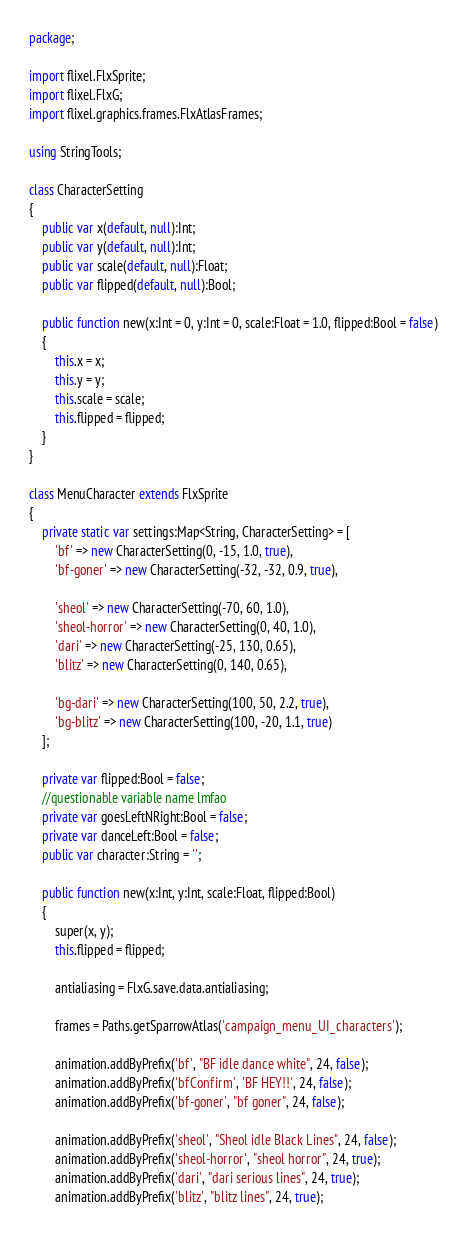<code> <loc_0><loc_0><loc_500><loc_500><_Haxe_>package;

import flixel.FlxSprite;
import flixel.FlxG;
import flixel.graphics.frames.FlxAtlasFrames;

using StringTools;

class CharacterSetting
{
	public var x(default, null):Int;
	public var y(default, null):Int;
	public var scale(default, null):Float;
	public var flipped(default, null):Bool;

	public function new(x:Int = 0, y:Int = 0, scale:Float = 1.0, flipped:Bool = false)
	{
		this.x = x;
		this.y = y;
		this.scale = scale;
		this.flipped = flipped;
	}
}

class MenuCharacter extends FlxSprite
{
	private static var settings:Map<String, CharacterSetting> = [
		'bf' => new CharacterSetting(0, -15, 1.0, true),
		'bf-goner' => new CharacterSetting(-32, -32, 0.9, true),

		'sheol' => new CharacterSetting(-70, 60, 1.0),
		'sheol-horror' => new CharacterSetting(0, 40, 1.0),
		'dari' => new CharacterSetting(-25, 130, 0.65),
		'blitz' => new CharacterSetting(0, 140, 0.65),

		'bg-dari' => new CharacterSetting(100, 50, 2.2, true),
		'bg-blitz' => new CharacterSetting(100, -20, 1.1, true)
	];

	private var flipped:Bool = false;
	//questionable variable name lmfao
	private var goesLeftNRight:Bool = false;
	private var danceLeft:Bool = false;
	public var character:String = '';

	public function new(x:Int, y:Int, scale:Float, flipped:Bool)
	{
		super(x, y);
		this.flipped = flipped;

		antialiasing = FlxG.save.data.antialiasing;

		frames = Paths.getSparrowAtlas('campaign_menu_UI_characters');

		animation.addByPrefix('bf', "BF idle dance white", 24, false);
		animation.addByPrefix('bfConfirm', 'BF HEY!!', 24, false);
		animation.addByPrefix('bf-goner', "bf goner", 24, false);

		animation.addByPrefix('sheol', "Sheol idle Black Lines", 24, false);
		animation.addByPrefix('sheol-horror', "sheol horror", 24, true);
		animation.addByPrefix('dari', "dari serious lines", 24, true);
		animation.addByPrefix('blitz', "blitz lines", 24, true);
</code> 